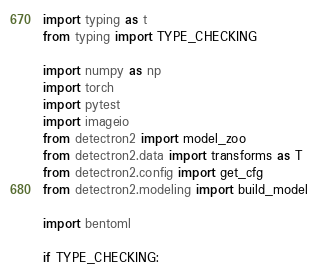<code> <loc_0><loc_0><loc_500><loc_500><_Python_>import typing as t
from typing import TYPE_CHECKING

import numpy as np
import torch
import pytest
import imageio
from detectron2 import model_zoo
from detectron2.data import transforms as T
from detectron2.config import get_cfg
from detectron2.modeling import build_model

import bentoml

if TYPE_CHECKING:</code> 